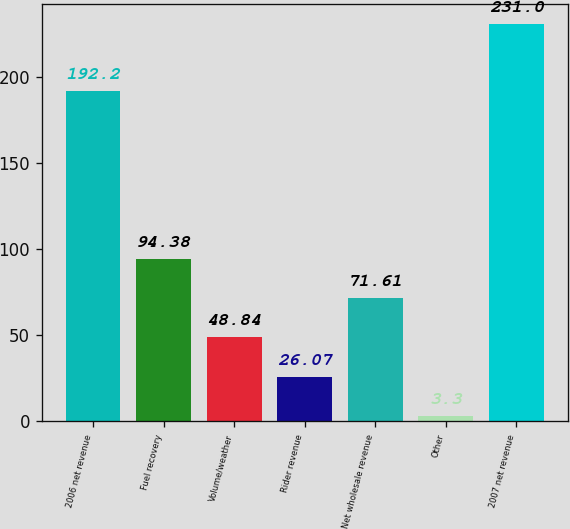Convert chart to OTSL. <chart><loc_0><loc_0><loc_500><loc_500><bar_chart><fcel>2006 net revenue<fcel>Fuel recovery<fcel>Volume/weather<fcel>Rider revenue<fcel>Net wholesale revenue<fcel>Other<fcel>2007 net revenue<nl><fcel>192.2<fcel>94.38<fcel>48.84<fcel>26.07<fcel>71.61<fcel>3.3<fcel>231<nl></chart> 